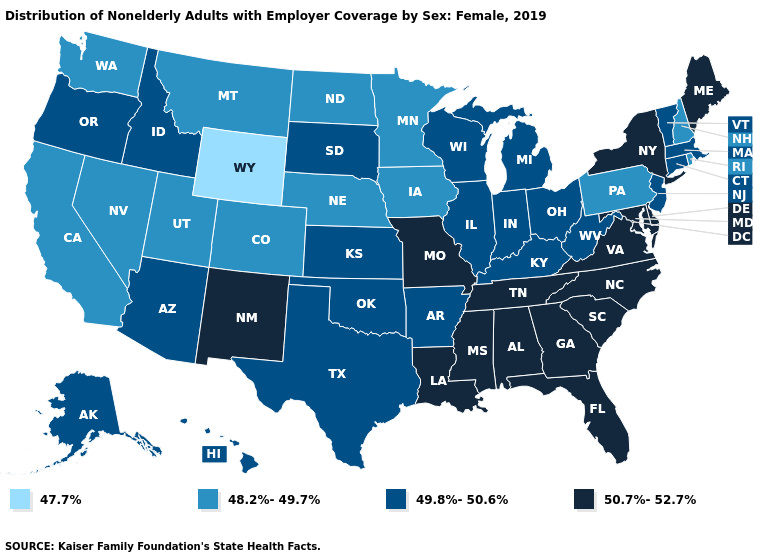Does Wyoming have the lowest value in the USA?
Be succinct. Yes. Does Wyoming have the lowest value in the West?
Keep it brief. Yes. Which states hav the highest value in the MidWest?
Write a very short answer. Missouri. Does Oklahoma have a higher value than New Hampshire?
Short answer required. Yes. What is the value of Indiana?
Short answer required. 49.8%-50.6%. What is the highest value in the USA?
Answer briefly. 50.7%-52.7%. What is the value of Missouri?
Answer briefly. 50.7%-52.7%. Which states hav the highest value in the MidWest?
Keep it brief. Missouri. What is the value of Idaho?
Give a very brief answer. 49.8%-50.6%. Which states hav the highest value in the South?
Quick response, please. Alabama, Delaware, Florida, Georgia, Louisiana, Maryland, Mississippi, North Carolina, South Carolina, Tennessee, Virginia. Does Maryland have the highest value in the USA?
Be succinct. Yes. What is the highest value in the MidWest ?
Keep it brief. 50.7%-52.7%. Name the states that have a value in the range 50.7%-52.7%?
Quick response, please. Alabama, Delaware, Florida, Georgia, Louisiana, Maine, Maryland, Mississippi, Missouri, New Mexico, New York, North Carolina, South Carolina, Tennessee, Virginia. Among the states that border Washington , which have the lowest value?
Quick response, please. Idaho, Oregon. 